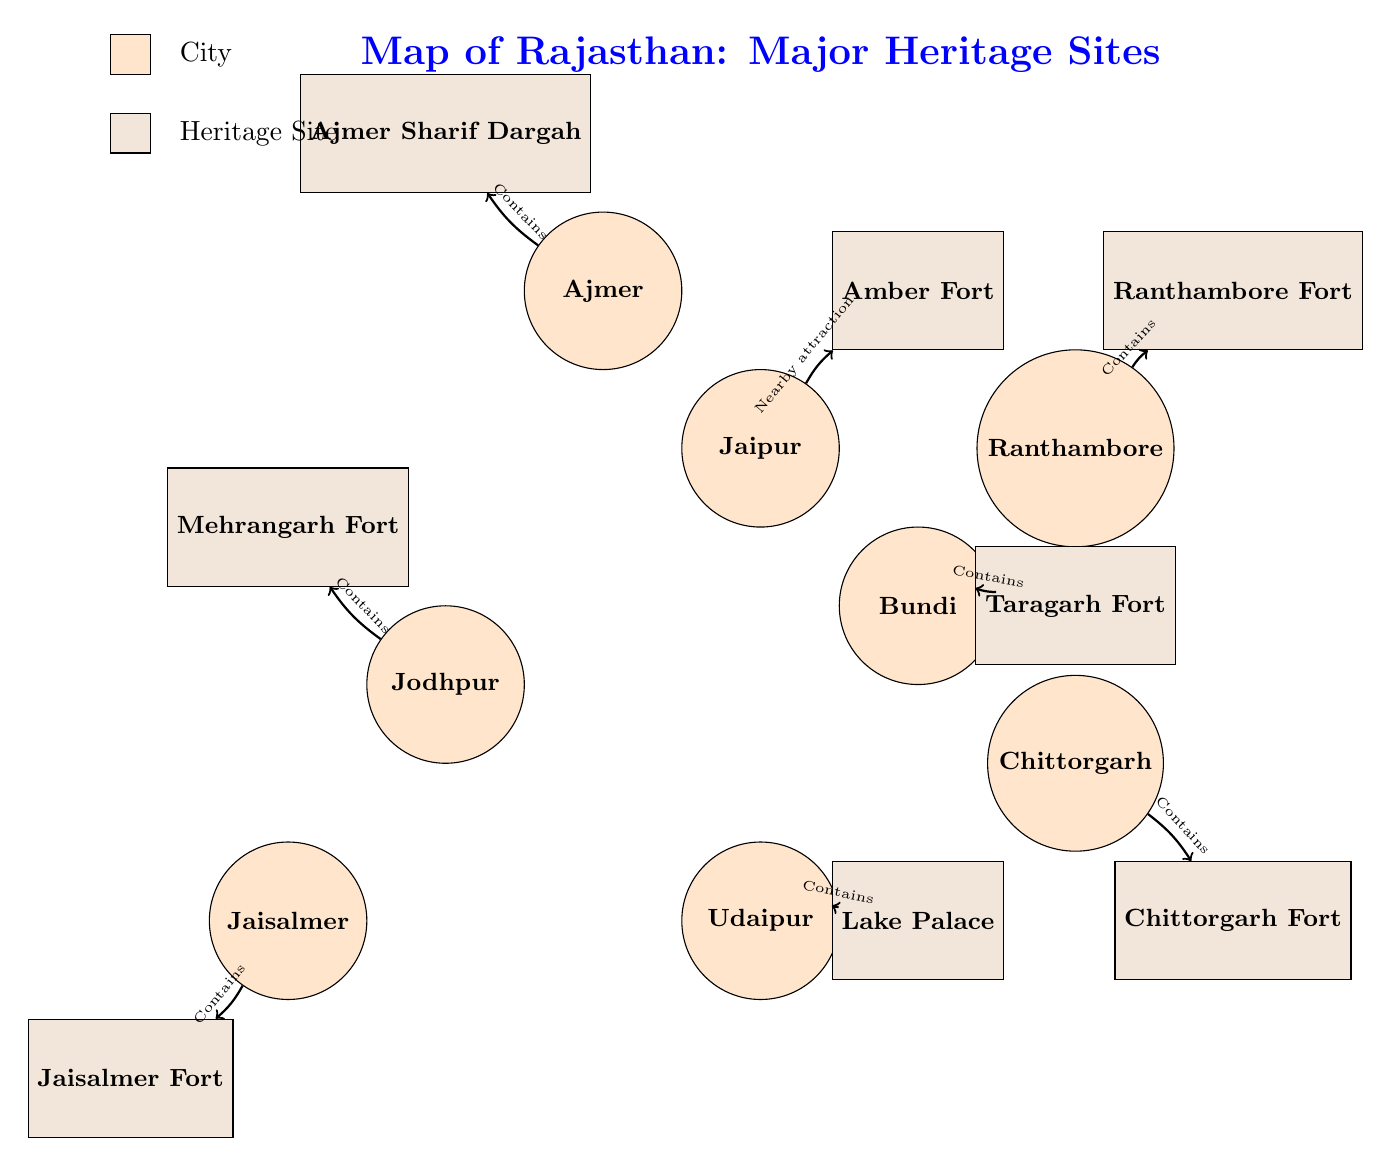What is the major heritage site in Udaipur? The diagram indicates that the heritage site associated with Udaipur is the Lake Palace. This can be found by looking for the city node 'Udaipur' and identifying the connected heritage site from the diagram.
Answer: Lake Palace How many cities are connected to heritage sites in this diagram? By counting the city nodes that have connections to heritage sites, we identify eight connections in total. Each city listed has at least one heritage site, making it a straightforward count.
Answer: 8 Which city features Mehrangarh Fort? In the diagram, Jodhpur is the city that connects to Mehrangarh Fort. This is determined by locating the Jodhpur node and identifying the heritage site it directly connects to.
Answer: Jodhpur What is the relation between Ajmer and its heritage site? The connection from the Ajmer node to its heritage site, Ajmer Sharif Dargah, specifies that the relationship is "Contains." Verifying this involves checking the arrow that leads from Ajmer to its corresponding heritage site.
Answer: Contains Which two cities are connected to Chittorgarh Fort? Chittorgarh connects to Chittorgarh Fort, and there are no other cities connected directly to this specific heritage site in the diagram. Thus, only Chittorgarh serves in this connection.
Answer: Chittorgarh How many heritage sites are represented on this map of Rajasthan? The diagram includes 7 heritage sites indicated by the heritage site nodes. Each node is categorized distinctly, and they can be tallied directly from the diagram.
Answer: 7 What is the significance of the arrow connections between the cities and heritage sites? The arrows show the relations, such as 'Contains' or 'Nearby attraction,' illustrating the type of connection each city has with its respective heritage site. This requires analyzing each arrow to understand the nature of the relationship.
Answer: Relation types Which city connects to Lake Palace? The diagram shows that Udaipur connects to the Lake Palace. This is evident through the direct connection from the Udaipur node to the heritage site node representing the Lake Palace.
Answer: Udaipur What color represents cities in the diagram? In the legend section of the diagram, it is clear that cities are represented by the color orange. This definition is found in the color code next to the label for cities.
Answer: Orange 